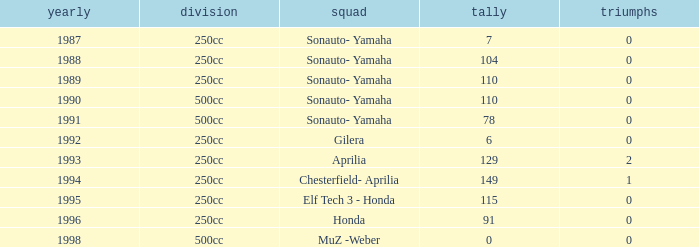How many wins did the team, which had more than 110 points, have in 1989? None. 